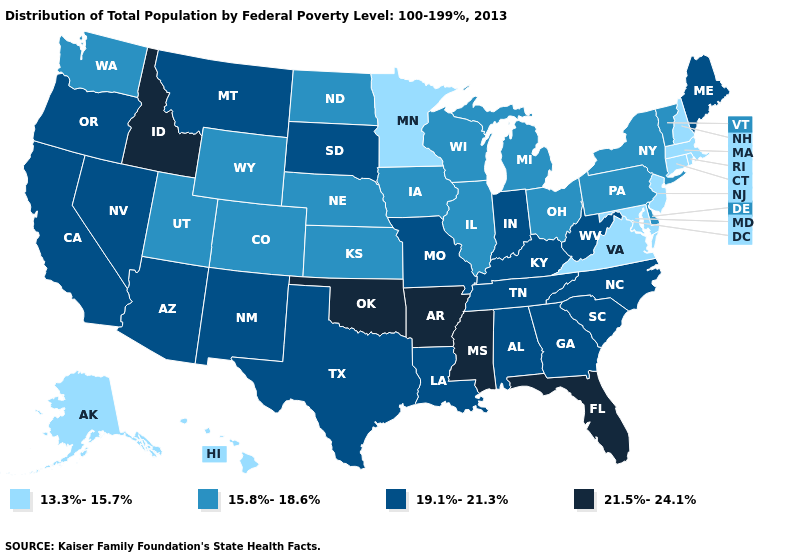Does Virginia have the lowest value in the South?
Write a very short answer. Yes. What is the value of Michigan?
Short answer required. 15.8%-18.6%. Name the states that have a value in the range 13.3%-15.7%?
Keep it brief. Alaska, Connecticut, Hawaii, Maryland, Massachusetts, Minnesota, New Hampshire, New Jersey, Rhode Island, Virginia. Does Washington have a lower value than Kentucky?
Short answer required. Yes. Which states have the highest value in the USA?
Give a very brief answer. Arkansas, Florida, Idaho, Mississippi, Oklahoma. What is the value of Arizona?
Short answer required. 19.1%-21.3%. Which states hav the highest value in the South?
Give a very brief answer. Arkansas, Florida, Mississippi, Oklahoma. Does Mississippi have the highest value in the USA?
Answer briefly. Yes. Name the states that have a value in the range 15.8%-18.6%?
Be succinct. Colorado, Delaware, Illinois, Iowa, Kansas, Michigan, Nebraska, New York, North Dakota, Ohio, Pennsylvania, Utah, Vermont, Washington, Wisconsin, Wyoming. Which states have the lowest value in the MidWest?
Keep it brief. Minnesota. What is the value of Arizona?
Short answer required. 19.1%-21.3%. What is the value of New Jersey?
Concise answer only. 13.3%-15.7%. Which states have the lowest value in the USA?
Quick response, please. Alaska, Connecticut, Hawaii, Maryland, Massachusetts, Minnesota, New Hampshire, New Jersey, Rhode Island, Virginia. Name the states that have a value in the range 19.1%-21.3%?
Be succinct. Alabama, Arizona, California, Georgia, Indiana, Kentucky, Louisiana, Maine, Missouri, Montana, Nevada, New Mexico, North Carolina, Oregon, South Carolina, South Dakota, Tennessee, Texas, West Virginia. Among the states that border Georgia , does Florida have the highest value?
Short answer required. Yes. 